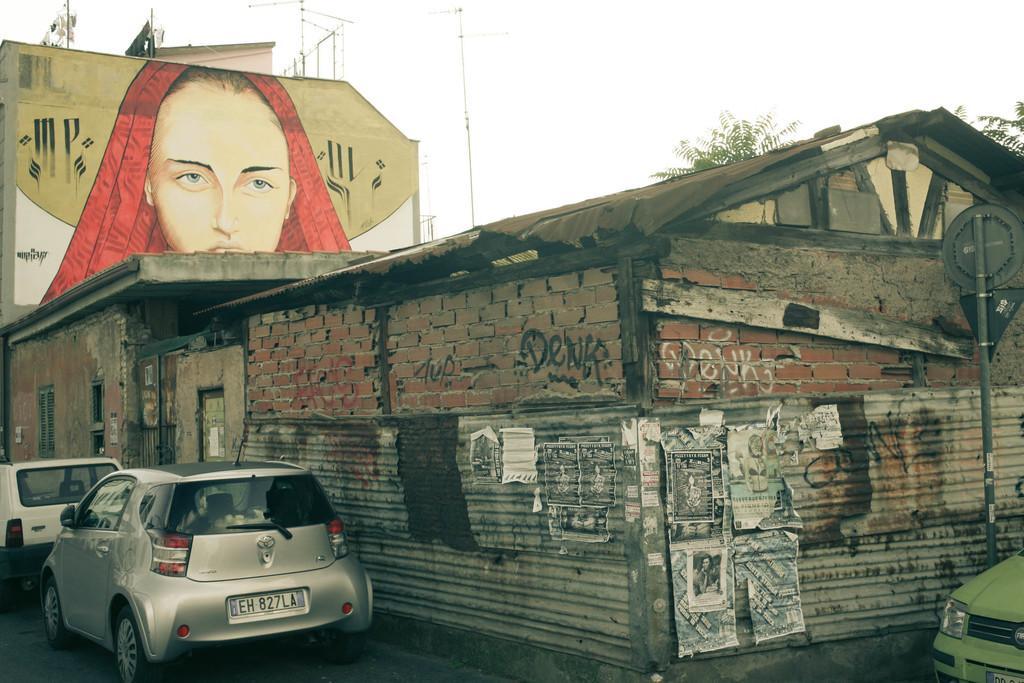Could you give a brief overview of what you see in this image? In this image we can see there are houses, behind it there is a painting of a person on the wall and there are trees and poles, at the bottom left corner of the image there are vehicles and at the bottom right corner there is a vehicle and a sign board, in the background we can see the sky. 